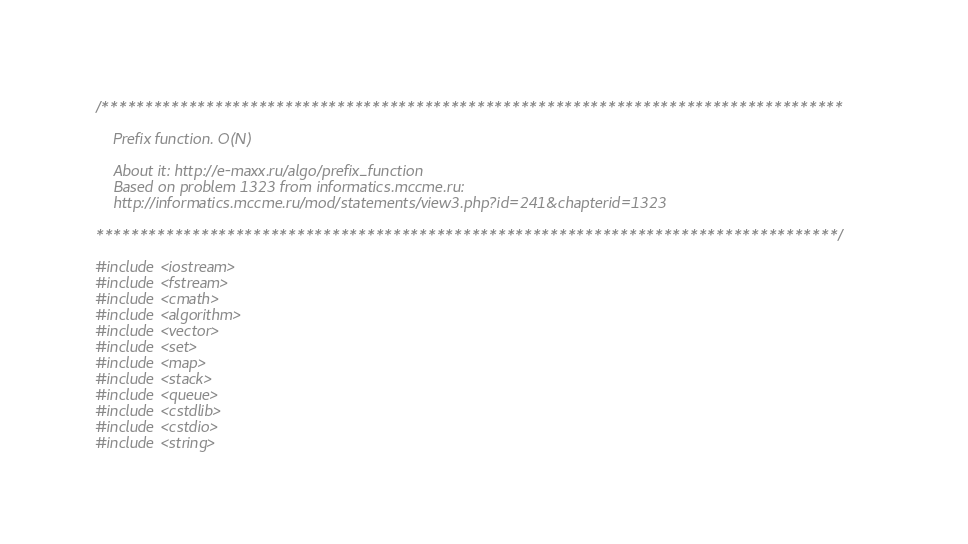Convert code to text. <code><loc_0><loc_0><loc_500><loc_500><_C++_>/*************************************************************************************

    Prefix function. O(N)

    About it: http://e-maxx.ru/algo/prefix_function
    Based on problem 1323 from informatics.mccme.ru:
    http://informatics.mccme.ru/mod/statements/view3.php?id=241&chapterid=1323

*************************************************************************************/

#include <iostream>
#include <fstream>
#include <cmath>
#include <algorithm>
#include <vector>
#include <set>
#include <map>
#include <stack>
#include <queue>
#include <cstdlib>
#include <cstdio>
#include <string></code> 